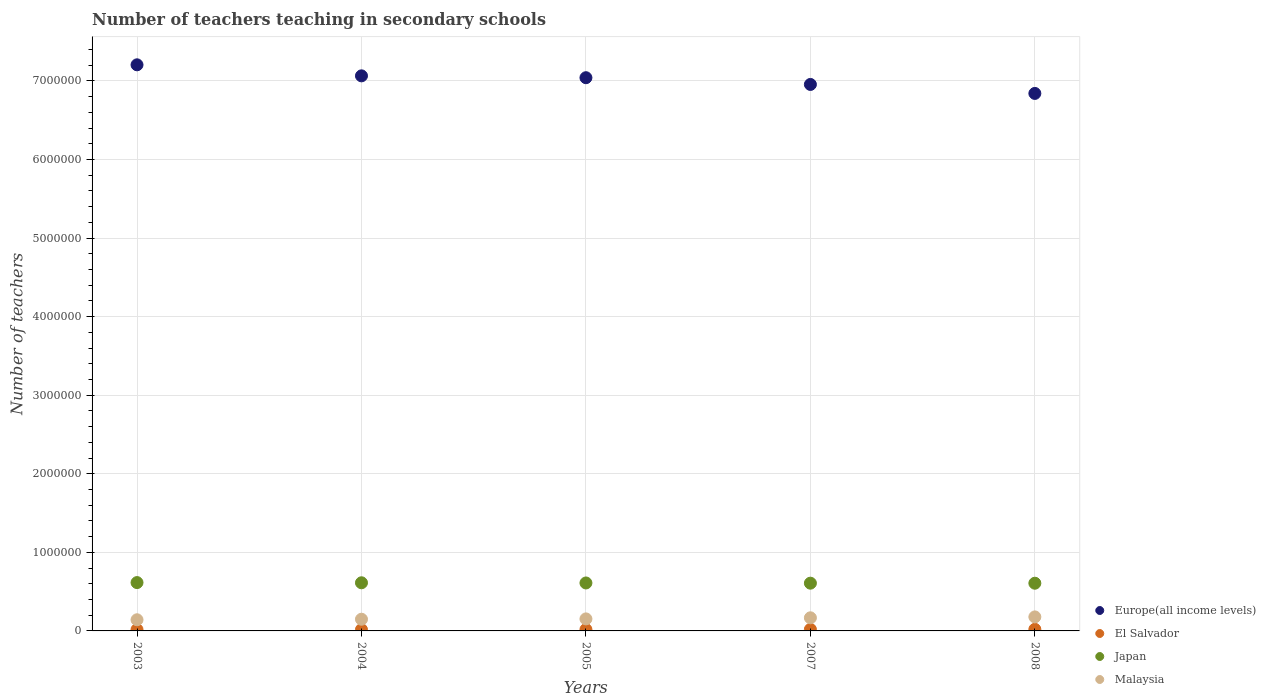Is the number of dotlines equal to the number of legend labels?
Offer a terse response. Yes. What is the number of teachers teaching in secondary schools in Europe(all income levels) in 2003?
Offer a terse response. 7.20e+06. Across all years, what is the maximum number of teachers teaching in secondary schools in Japan?
Give a very brief answer. 6.15e+05. Across all years, what is the minimum number of teachers teaching in secondary schools in Europe(all income levels)?
Your answer should be very brief. 6.84e+06. In which year was the number of teachers teaching in secondary schools in Japan maximum?
Your answer should be very brief. 2003. What is the total number of teachers teaching in secondary schools in Malaysia in the graph?
Give a very brief answer. 7.89e+05. What is the difference between the number of teachers teaching in secondary schools in Japan in 2003 and that in 2007?
Ensure brevity in your answer.  7495. What is the difference between the number of teachers teaching in secondary schools in Malaysia in 2005 and the number of teachers teaching in secondary schools in Japan in 2008?
Provide a short and direct response. -4.54e+05. What is the average number of teachers teaching in secondary schools in Europe(all income levels) per year?
Offer a very short reply. 7.02e+06. In the year 2003, what is the difference between the number of teachers teaching in secondary schools in Malaysia and number of teachers teaching in secondary schools in Japan?
Your response must be concise. -4.73e+05. What is the ratio of the number of teachers teaching in secondary schools in El Salvador in 2005 to that in 2007?
Provide a succinct answer. 0.91. What is the difference between the highest and the second highest number of teachers teaching in secondary schools in Japan?
Offer a terse response. 2529. What is the difference between the highest and the lowest number of teachers teaching in secondary schools in El Salvador?
Provide a short and direct response. 3652. In how many years, is the number of teachers teaching in secondary schools in El Salvador greater than the average number of teachers teaching in secondary schools in El Salvador taken over all years?
Your answer should be very brief. 2. Is the sum of the number of teachers teaching in secondary schools in Japan in 2003 and 2004 greater than the maximum number of teachers teaching in secondary schools in Malaysia across all years?
Your response must be concise. Yes. Is it the case that in every year, the sum of the number of teachers teaching in secondary schools in Europe(all income levels) and number of teachers teaching in secondary schools in Malaysia  is greater than the sum of number of teachers teaching in secondary schools in Japan and number of teachers teaching in secondary schools in El Salvador?
Your answer should be compact. Yes. Does the number of teachers teaching in secondary schools in Europe(all income levels) monotonically increase over the years?
Offer a very short reply. No. Is the number of teachers teaching in secondary schools in El Salvador strictly greater than the number of teachers teaching in secondary schools in Malaysia over the years?
Give a very brief answer. No. Is the number of teachers teaching in secondary schools in Japan strictly less than the number of teachers teaching in secondary schools in Europe(all income levels) over the years?
Make the answer very short. Yes. How many dotlines are there?
Your response must be concise. 4. Are the values on the major ticks of Y-axis written in scientific E-notation?
Provide a short and direct response. No. Where does the legend appear in the graph?
Offer a terse response. Bottom right. How many legend labels are there?
Your answer should be compact. 4. How are the legend labels stacked?
Your answer should be very brief. Vertical. What is the title of the graph?
Offer a very short reply. Number of teachers teaching in secondary schools. Does "Belarus" appear as one of the legend labels in the graph?
Offer a terse response. No. What is the label or title of the X-axis?
Give a very brief answer. Years. What is the label or title of the Y-axis?
Provide a short and direct response. Number of teachers. What is the Number of teachers of Europe(all income levels) in 2003?
Provide a short and direct response. 7.20e+06. What is the Number of teachers of El Salvador in 2003?
Your answer should be very brief. 1.68e+04. What is the Number of teachers in Japan in 2003?
Offer a very short reply. 6.15e+05. What is the Number of teachers in Malaysia in 2003?
Your answer should be very brief. 1.42e+05. What is the Number of teachers in Europe(all income levels) in 2004?
Offer a terse response. 7.06e+06. What is the Number of teachers of El Salvador in 2004?
Provide a succinct answer. 1.72e+04. What is the Number of teachers of Japan in 2004?
Provide a succinct answer. 6.13e+05. What is the Number of teachers of Malaysia in 2004?
Keep it short and to the point. 1.49e+05. What is the Number of teachers of Europe(all income levels) in 2005?
Provide a succinct answer. 7.04e+06. What is the Number of teachers in El Salvador in 2005?
Offer a very short reply. 1.81e+04. What is the Number of teachers of Japan in 2005?
Ensure brevity in your answer.  6.10e+05. What is the Number of teachers in Malaysia in 2005?
Make the answer very short. 1.53e+05. What is the Number of teachers of Europe(all income levels) in 2007?
Make the answer very short. 6.95e+06. What is the Number of teachers in El Salvador in 2007?
Your answer should be compact. 1.99e+04. What is the Number of teachers of Japan in 2007?
Your answer should be compact. 6.08e+05. What is the Number of teachers in Malaysia in 2007?
Your answer should be compact. 1.67e+05. What is the Number of teachers of Europe(all income levels) in 2008?
Offer a very short reply. 6.84e+06. What is the Number of teachers in El Salvador in 2008?
Provide a succinct answer. 2.05e+04. What is the Number of teachers of Japan in 2008?
Keep it short and to the point. 6.07e+05. What is the Number of teachers of Malaysia in 2008?
Provide a short and direct response. 1.78e+05. Across all years, what is the maximum Number of teachers in Europe(all income levels)?
Your response must be concise. 7.20e+06. Across all years, what is the maximum Number of teachers in El Salvador?
Make the answer very short. 2.05e+04. Across all years, what is the maximum Number of teachers of Japan?
Provide a short and direct response. 6.15e+05. Across all years, what is the maximum Number of teachers in Malaysia?
Provide a short and direct response. 1.78e+05. Across all years, what is the minimum Number of teachers in Europe(all income levels)?
Provide a succinct answer. 6.84e+06. Across all years, what is the minimum Number of teachers of El Salvador?
Your answer should be very brief. 1.68e+04. Across all years, what is the minimum Number of teachers of Japan?
Provide a short and direct response. 6.07e+05. Across all years, what is the minimum Number of teachers in Malaysia?
Offer a very short reply. 1.42e+05. What is the total Number of teachers of Europe(all income levels) in the graph?
Give a very brief answer. 3.51e+07. What is the total Number of teachers in El Salvador in the graph?
Offer a terse response. 9.26e+04. What is the total Number of teachers in Japan in the graph?
Your answer should be compact. 3.05e+06. What is the total Number of teachers in Malaysia in the graph?
Make the answer very short. 7.89e+05. What is the difference between the Number of teachers in Europe(all income levels) in 2003 and that in 2004?
Your response must be concise. 1.40e+05. What is the difference between the Number of teachers of El Salvador in 2003 and that in 2004?
Ensure brevity in your answer.  -367. What is the difference between the Number of teachers in Japan in 2003 and that in 2004?
Make the answer very short. 2529. What is the difference between the Number of teachers in Malaysia in 2003 and that in 2004?
Ensure brevity in your answer.  -6911. What is the difference between the Number of teachers of Europe(all income levels) in 2003 and that in 2005?
Make the answer very short. 1.64e+05. What is the difference between the Number of teachers in El Salvador in 2003 and that in 2005?
Offer a very short reply. -1294. What is the difference between the Number of teachers of Japan in 2003 and that in 2005?
Offer a terse response. 4786. What is the difference between the Number of teachers of Malaysia in 2003 and that in 2005?
Ensure brevity in your answer.  -1.11e+04. What is the difference between the Number of teachers in Europe(all income levels) in 2003 and that in 2007?
Provide a short and direct response. 2.50e+05. What is the difference between the Number of teachers in El Salvador in 2003 and that in 2007?
Keep it short and to the point. -3097. What is the difference between the Number of teachers of Japan in 2003 and that in 2007?
Provide a short and direct response. 7495. What is the difference between the Number of teachers of Malaysia in 2003 and that in 2007?
Provide a short and direct response. -2.50e+04. What is the difference between the Number of teachers in Europe(all income levels) in 2003 and that in 2008?
Offer a very short reply. 3.64e+05. What is the difference between the Number of teachers of El Salvador in 2003 and that in 2008?
Ensure brevity in your answer.  -3652. What is the difference between the Number of teachers of Japan in 2003 and that in 2008?
Give a very brief answer. 8096. What is the difference between the Number of teachers of Malaysia in 2003 and that in 2008?
Your response must be concise. -3.65e+04. What is the difference between the Number of teachers of Europe(all income levels) in 2004 and that in 2005?
Provide a succinct answer. 2.37e+04. What is the difference between the Number of teachers of El Salvador in 2004 and that in 2005?
Offer a terse response. -927. What is the difference between the Number of teachers in Japan in 2004 and that in 2005?
Offer a very short reply. 2257. What is the difference between the Number of teachers in Malaysia in 2004 and that in 2005?
Make the answer very short. -4207. What is the difference between the Number of teachers in Europe(all income levels) in 2004 and that in 2007?
Ensure brevity in your answer.  1.09e+05. What is the difference between the Number of teachers of El Salvador in 2004 and that in 2007?
Offer a very short reply. -2730. What is the difference between the Number of teachers of Japan in 2004 and that in 2007?
Make the answer very short. 4966. What is the difference between the Number of teachers of Malaysia in 2004 and that in 2007?
Provide a short and direct response. -1.81e+04. What is the difference between the Number of teachers in Europe(all income levels) in 2004 and that in 2008?
Ensure brevity in your answer.  2.24e+05. What is the difference between the Number of teachers in El Salvador in 2004 and that in 2008?
Make the answer very short. -3285. What is the difference between the Number of teachers of Japan in 2004 and that in 2008?
Your answer should be very brief. 5567. What is the difference between the Number of teachers of Malaysia in 2004 and that in 2008?
Provide a short and direct response. -2.96e+04. What is the difference between the Number of teachers of Europe(all income levels) in 2005 and that in 2007?
Your response must be concise. 8.57e+04. What is the difference between the Number of teachers in El Salvador in 2005 and that in 2007?
Make the answer very short. -1803. What is the difference between the Number of teachers in Japan in 2005 and that in 2007?
Make the answer very short. 2709. What is the difference between the Number of teachers in Malaysia in 2005 and that in 2007?
Give a very brief answer. -1.39e+04. What is the difference between the Number of teachers of Europe(all income levels) in 2005 and that in 2008?
Provide a short and direct response. 2.00e+05. What is the difference between the Number of teachers in El Salvador in 2005 and that in 2008?
Offer a terse response. -2358. What is the difference between the Number of teachers of Japan in 2005 and that in 2008?
Your answer should be very brief. 3310. What is the difference between the Number of teachers in Malaysia in 2005 and that in 2008?
Offer a terse response. -2.53e+04. What is the difference between the Number of teachers in Europe(all income levels) in 2007 and that in 2008?
Your response must be concise. 1.14e+05. What is the difference between the Number of teachers of El Salvador in 2007 and that in 2008?
Offer a terse response. -555. What is the difference between the Number of teachers of Japan in 2007 and that in 2008?
Ensure brevity in your answer.  601. What is the difference between the Number of teachers in Malaysia in 2007 and that in 2008?
Offer a terse response. -1.14e+04. What is the difference between the Number of teachers of Europe(all income levels) in 2003 and the Number of teachers of El Salvador in 2004?
Offer a very short reply. 7.19e+06. What is the difference between the Number of teachers in Europe(all income levels) in 2003 and the Number of teachers in Japan in 2004?
Your response must be concise. 6.59e+06. What is the difference between the Number of teachers of Europe(all income levels) in 2003 and the Number of teachers of Malaysia in 2004?
Your answer should be compact. 7.06e+06. What is the difference between the Number of teachers of El Salvador in 2003 and the Number of teachers of Japan in 2004?
Offer a terse response. -5.96e+05. What is the difference between the Number of teachers of El Salvador in 2003 and the Number of teachers of Malaysia in 2004?
Your response must be concise. -1.32e+05. What is the difference between the Number of teachers of Japan in 2003 and the Number of teachers of Malaysia in 2004?
Your response must be concise. 4.66e+05. What is the difference between the Number of teachers of Europe(all income levels) in 2003 and the Number of teachers of El Salvador in 2005?
Ensure brevity in your answer.  7.19e+06. What is the difference between the Number of teachers in Europe(all income levels) in 2003 and the Number of teachers in Japan in 2005?
Offer a very short reply. 6.59e+06. What is the difference between the Number of teachers in Europe(all income levels) in 2003 and the Number of teachers in Malaysia in 2005?
Provide a short and direct response. 7.05e+06. What is the difference between the Number of teachers of El Salvador in 2003 and the Number of teachers of Japan in 2005?
Offer a terse response. -5.94e+05. What is the difference between the Number of teachers in El Salvador in 2003 and the Number of teachers in Malaysia in 2005?
Offer a terse response. -1.36e+05. What is the difference between the Number of teachers of Japan in 2003 and the Number of teachers of Malaysia in 2005?
Your answer should be compact. 4.62e+05. What is the difference between the Number of teachers of Europe(all income levels) in 2003 and the Number of teachers of El Salvador in 2007?
Offer a terse response. 7.18e+06. What is the difference between the Number of teachers of Europe(all income levels) in 2003 and the Number of teachers of Japan in 2007?
Give a very brief answer. 6.60e+06. What is the difference between the Number of teachers of Europe(all income levels) in 2003 and the Number of teachers of Malaysia in 2007?
Ensure brevity in your answer.  7.04e+06. What is the difference between the Number of teachers in El Salvador in 2003 and the Number of teachers in Japan in 2007?
Your response must be concise. -5.91e+05. What is the difference between the Number of teachers in El Salvador in 2003 and the Number of teachers in Malaysia in 2007?
Give a very brief answer. -1.50e+05. What is the difference between the Number of teachers in Japan in 2003 and the Number of teachers in Malaysia in 2007?
Keep it short and to the point. 4.48e+05. What is the difference between the Number of teachers of Europe(all income levels) in 2003 and the Number of teachers of El Salvador in 2008?
Give a very brief answer. 7.18e+06. What is the difference between the Number of teachers in Europe(all income levels) in 2003 and the Number of teachers in Japan in 2008?
Offer a very short reply. 6.60e+06. What is the difference between the Number of teachers in Europe(all income levels) in 2003 and the Number of teachers in Malaysia in 2008?
Your answer should be very brief. 7.03e+06. What is the difference between the Number of teachers in El Salvador in 2003 and the Number of teachers in Japan in 2008?
Keep it short and to the point. -5.90e+05. What is the difference between the Number of teachers in El Salvador in 2003 and the Number of teachers in Malaysia in 2008?
Provide a short and direct response. -1.62e+05. What is the difference between the Number of teachers of Japan in 2003 and the Number of teachers of Malaysia in 2008?
Your answer should be compact. 4.37e+05. What is the difference between the Number of teachers in Europe(all income levels) in 2004 and the Number of teachers in El Salvador in 2005?
Ensure brevity in your answer.  7.05e+06. What is the difference between the Number of teachers in Europe(all income levels) in 2004 and the Number of teachers in Japan in 2005?
Offer a terse response. 6.45e+06. What is the difference between the Number of teachers in Europe(all income levels) in 2004 and the Number of teachers in Malaysia in 2005?
Provide a succinct answer. 6.91e+06. What is the difference between the Number of teachers in El Salvador in 2004 and the Number of teachers in Japan in 2005?
Provide a succinct answer. -5.93e+05. What is the difference between the Number of teachers of El Salvador in 2004 and the Number of teachers of Malaysia in 2005?
Ensure brevity in your answer.  -1.36e+05. What is the difference between the Number of teachers of Japan in 2004 and the Number of teachers of Malaysia in 2005?
Keep it short and to the point. 4.60e+05. What is the difference between the Number of teachers in Europe(all income levels) in 2004 and the Number of teachers in El Salvador in 2007?
Offer a very short reply. 7.04e+06. What is the difference between the Number of teachers in Europe(all income levels) in 2004 and the Number of teachers in Japan in 2007?
Keep it short and to the point. 6.46e+06. What is the difference between the Number of teachers of Europe(all income levels) in 2004 and the Number of teachers of Malaysia in 2007?
Ensure brevity in your answer.  6.90e+06. What is the difference between the Number of teachers of El Salvador in 2004 and the Number of teachers of Japan in 2007?
Ensure brevity in your answer.  -5.90e+05. What is the difference between the Number of teachers of El Salvador in 2004 and the Number of teachers of Malaysia in 2007?
Your answer should be compact. -1.50e+05. What is the difference between the Number of teachers in Japan in 2004 and the Number of teachers in Malaysia in 2007?
Offer a very short reply. 4.46e+05. What is the difference between the Number of teachers in Europe(all income levels) in 2004 and the Number of teachers in El Salvador in 2008?
Keep it short and to the point. 7.04e+06. What is the difference between the Number of teachers in Europe(all income levels) in 2004 and the Number of teachers in Japan in 2008?
Provide a succinct answer. 6.46e+06. What is the difference between the Number of teachers of Europe(all income levels) in 2004 and the Number of teachers of Malaysia in 2008?
Your answer should be compact. 6.89e+06. What is the difference between the Number of teachers of El Salvador in 2004 and the Number of teachers of Japan in 2008?
Give a very brief answer. -5.90e+05. What is the difference between the Number of teachers of El Salvador in 2004 and the Number of teachers of Malaysia in 2008?
Your response must be concise. -1.61e+05. What is the difference between the Number of teachers of Japan in 2004 and the Number of teachers of Malaysia in 2008?
Your answer should be compact. 4.34e+05. What is the difference between the Number of teachers in Europe(all income levels) in 2005 and the Number of teachers in El Salvador in 2007?
Keep it short and to the point. 7.02e+06. What is the difference between the Number of teachers of Europe(all income levels) in 2005 and the Number of teachers of Japan in 2007?
Give a very brief answer. 6.43e+06. What is the difference between the Number of teachers of Europe(all income levels) in 2005 and the Number of teachers of Malaysia in 2007?
Provide a succinct answer. 6.87e+06. What is the difference between the Number of teachers in El Salvador in 2005 and the Number of teachers in Japan in 2007?
Give a very brief answer. -5.90e+05. What is the difference between the Number of teachers of El Salvador in 2005 and the Number of teachers of Malaysia in 2007?
Offer a terse response. -1.49e+05. What is the difference between the Number of teachers in Japan in 2005 and the Number of teachers in Malaysia in 2007?
Make the answer very short. 4.43e+05. What is the difference between the Number of teachers in Europe(all income levels) in 2005 and the Number of teachers in El Salvador in 2008?
Offer a very short reply. 7.02e+06. What is the difference between the Number of teachers in Europe(all income levels) in 2005 and the Number of teachers in Japan in 2008?
Give a very brief answer. 6.43e+06. What is the difference between the Number of teachers of Europe(all income levels) in 2005 and the Number of teachers of Malaysia in 2008?
Provide a succinct answer. 6.86e+06. What is the difference between the Number of teachers of El Salvador in 2005 and the Number of teachers of Japan in 2008?
Keep it short and to the point. -5.89e+05. What is the difference between the Number of teachers in El Salvador in 2005 and the Number of teachers in Malaysia in 2008?
Your answer should be compact. -1.60e+05. What is the difference between the Number of teachers in Japan in 2005 and the Number of teachers in Malaysia in 2008?
Offer a very short reply. 4.32e+05. What is the difference between the Number of teachers in Europe(all income levels) in 2007 and the Number of teachers in El Salvador in 2008?
Offer a very short reply. 6.93e+06. What is the difference between the Number of teachers in Europe(all income levels) in 2007 and the Number of teachers in Japan in 2008?
Offer a terse response. 6.35e+06. What is the difference between the Number of teachers of Europe(all income levels) in 2007 and the Number of teachers of Malaysia in 2008?
Your answer should be very brief. 6.78e+06. What is the difference between the Number of teachers in El Salvador in 2007 and the Number of teachers in Japan in 2008?
Your response must be concise. -5.87e+05. What is the difference between the Number of teachers of El Salvador in 2007 and the Number of teachers of Malaysia in 2008?
Give a very brief answer. -1.58e+05. What is the difference between the Number of teachers of Japan in 2007 and the Number of teachers of Malaysia in 2008?
Keep it short and to the point. 4.29e+05. What is the average Number of teachers of Europe(all income levels) per year?
Provide a succinct answer. 7.02e+06. What is the average Number of teachers of El Salvador per year?
Offer a very short reply. 1.85e+04. What is the average Number of teachers in Japan per year?
Give a very brief answer. 6.11e+05. What is the average Number of teachers in Malaysia per year?
Keep it short and to the point. 1.58e+05. In the year 2003, what is the difference between the Number of teachers of Europe(all income levels) and Number of teachers of El Salvador?
Your response must be concise. 7.19e+06. In the year 2003, what is the difference between the Number of teachers of Europe(all income levels) and Number of teachers of Japan?
Make the answer very short. 6.59e+06. In the year 2003, what is the difference between the Number of teachers in Europe(all income levels) and Number of teachers in Malaysia?
Your response must be concise. 7.06e+06. In the year 2003, what is the difference between the Number of teachers of El Salvador and Number of teachers of Japan?
Make the answer very short. -5.98e+05. In the year 2003, what is the difference between the Number of teachers in El Salvador and Number of teachers in Malaysia?
Your answer should be compact. -1.25e+05. In the year 2003, what is the difference between the Number of teachers in Japan and Number of teachers in Malaysia?
Your answer should be compact. 4.73e+05. In the year 2004, what is the difference between the Number of teachers in Europe(all income levels) and Number of teachers in El Salvador?
Give a very brief answer. 7.05e+06. In the year 2004, what is the difference between the Number of teachers in Europe(all income levels) and Number of teachers in Japan?
Give a very brief answer. 6.45e+06. In the year 2004, what is the difference between the Number of teachers of Europe(all income levels) and Number of teachers of Malaysia?
Keep it short and to the point. 6.92e+06. In the year 2004, what is the difference between the Number of teachers in El Salvador and Number of teachers in Japan?
Provide a short and direct response. -5.95e+05. In the year 2004, what is the difference between the Number of teachers of El Salvador and Number of teachers of Malaysia?
Ensure brevity in your answer.  -1.32e+05. In the year 2004, what is the difference between the Number of teachers of Japan and Number of teachers of Malaysia?
Offer a very short reply. 4.64e+05. In the year 2005, what is the difference between the Number of teachers of Europe(all income levels) and Number of teachers of El Salvador?
Provide a succinct answer. 7.02e+06. In the year 2005, what is the difference between the Number of teachers of Europe(all income levels) and Number of teachers of Japan?
Provide a short and direct response. 6.43e+06. In the year 2005, what is the difference between the Number of teachers of Europe(all income levels) and Number of teachers of Malaysia?
Provide a succinct answer. 6.89e+06. In the year 2005, what is the difference between the Number of teachers in El Salvador and Number of teachers in Japan?
Give a very brief answer. -5.92e+05. In the year 2005, what is the difference between the Number of teachers of El Salvador and Number of teachers of Malaysia?
Provide a short and direct response. -1.35e+05. In the year 2005, what is the difference between the Number of teachers of Japan and Number of teachers of Malaysia?
Keep it short and to the point. 4.57e+05. In the year 2007, what is the difference between the Number of teachers of Europe(all income levels) and Number of teachers of El Salvador?
Provide a short and direct response. 6.93e+06. In the year 2007, what is the difference between the Number of teachers in Europe(all income levels) and Number of teachers in Japan?
Make the answer very short. 6.35e+06. In the year 2007, what is the difference between the Number of teachers in Europe(all income levels) and Number of teachers in Malaysia?
Your answer should be very brief. 6.79e+06. In the year 2007, what is the difference between the Number of teachers of El Salvador and Number of teachers of Japan?
Your answer should be compact. -5.88e+05. In the year 2007, what is the difference between the Number of teachers of El Salvador and Number of teachers of Malaysia?
Provide a succinct answer. -1.47e+05. In the year 2007, what is the difference between the Number of teachers in Japan and Number of teachers in Malaysia?
Provide a short and direct response. 4.41e+05. In the year 2008, what is the difference between the Number of teachers of Europe(all income levels) and Number of teachers of El Salvador?
Provide a succinct answer. 6.82e+06. In the year 2008, what is the difference between the Number of teachers of Europe(all income levels) and Number of teachers of Japan?
Your answer should be very brief. 6.23e+06. In the year 2008, what is the difference between the Number of teachers of Europe(all income levels) and Number of teachers of Malaysia?
Your answer should be very brief. 6.66e+06. In the year 2008, what is the difference between the Number of teachers in El Salvador and Number of teachers in Japan?
Offer a terse response. -5.87e+05. In the year 2008, what is the difference between the Number of teachers of El Salvador and Number of teachers of Malaysia?
Your response must be concise. -1.58e+05. In the year 2008, what is the difference between the Number of teachers in Japan and Number of teachers in Malaysia?
Your answer should be compact. 4.29e+05. What is the ratio of the Number of teachers in Europe(all income levels) in 2003 to that in 2004?
Give a very brief answer. 1.02. What is the ratio of the Number of teachers of El Salvador in 2003 to that in 2004?
Provide a succinct answer. 0.98. What is the ratio of the Number of teachers in Malaysia in 2003 to that in 2004?
Your answer should be compact. 0.95. What is the ratio of the Number of teachers in Europe(all income levels) in 2003 to that in 2005?
Make the answer very short. 1.02. What is the ratio of the Number of teachers of El Salvador in 2003 to that in 2005?
Make the answer very short. 0.93. What is the ratio of the Number of teachers of Malaysia in 2003 to that in 2005?
Your answer should be very brief. 0.93. What is the ratio of the Number of teachers in Europe(all income levels) in 2003 to that in 2007?
Provide a short and direct response. 1.04. What is the ratio of the Number of teachers in El Salvador in 2003 to that in 2007?
Give a very brief answer. 0.84. What is the ratio of the Number of teachers of Japan in 2003 to that in 2007?
Provide a short and direct response. 1.01. What is the ratio of the Number of teachers in Malaysia in 2003 to that in 2007?
Make the answer very short. 0.85. What is the ratio of the Number of teachers in Europe(all income levels) in 2003 to that in 2008?
Keep it short and to the point. 1.05. What is the ratio of the Number of teachers in El Salvador in 2003 to that in 2008?
Make the answer very short. 0.82. What is the ratio of the Number of teachers of Japan in 2003 to that in 2008?
Keep it short and to the point. 1.01. What is the ratio of the Number of teachers of Malaysia in 2003 to that in 2008?
Give a very brief answer. 0.8. What is the ratio of the Number of teachers of El Salvador in 2004 to that in 2005?
Offer a terse response. 0.95. What is the ratio of the Number of teachers of Japan in 2004 to that in 2005?
Offer a terse response. 1. What is the ratio of the Number of teachers of Malaysia in 2004 to that in 2005?
Provide a short and direct response. 0.97. What is the ratio of the Number of teachers of Europe(all income levels) in 2004 to that in 2007?
Provide a short and direct response. 1.02. What is the ratio of the Number of teachers in El Salvador in 2004 to that in 2007?
Keep it short and to the point. 0.86. What is the ratio of the Number of teachers in Japan in 2004 to that in 2007?
Your answer should be compact. 1.01. What is the ratio of the Number of teachers in Malaysia in 2004 to that in 2007?
Provide a short and direct response. 0.89. What is the ratio of the Number of teachers in Europe(all income levels) in 2004 to that in 2008?
Ensure brevity in your answer.  1.03. What is the ratio of the Number of teachers in El Salvador in 2004 to that in 2008?
Offer a terse response. 0.84. What is the ratio of the Number of teachers in Japan in 2004 to that in 2008?
Your answer should be compact. 1.01. What is the ratio of the Number of teachers in Malaysia in 2004 to that in 2008?
Your response must be concise. 0.83. What is the ratio of the Number of teachers in Europe(all income levels) in 2005 to that in 2007?
Offer a terse response. 1.01. What is the ratio of the Number of teachers of El Salvador in 2005 to that in 2007?
Provide a succinct answer. 0.91. What is the ratio of the Number of teachers in Japan in 2005 to that in 2007?
Offer a very short reply. 1. What is the ratio of the Number of teachers of Europe(all income levels) in 2005 to that in 2008?
Offer a terse response. 1.03. What is the ratio of the Number of teachers of El Salvador in 2005 to that in 2008?
Ensure brevity in your answer.  0.88. What is the ratio of the Number of teachers of Malaysia in 2005 to that in 2008?
Offer a very short reply. 0.86. What is the ratio of the Number of teachers in Europe(all income levels) in 2007 to that in 2008?
Your answer should be compact. 1.02. What is the ratio of the Number of teachers in El Salvador in 2007 to that in 2008?
Your answer should be very brief. 0.97. What is the ratio of the Number of teachers of Malaysia in 2007 to that in 2008?
Offer a very short reply. 0.94. What is the difference between the highest and the second highest Number of teachers of Europe(all income levels)?
Provide a succinct answer. 1.40e+05. What is the difference between the highest and the second highest Number of teachers of El Salvador?
Give a very brief answer. 555. What is the difference between the highest and the second highest Number of teachers of Japan?
Your response must be concise. 2529. What is the difference between the highest and the second highest Number of teachers of Malaysia?
Offer a very short reply. 1.14e+04. What is the difference between the highest and the lowest Number of teachers of Europe(all income levels)?
Your answer should be very brief. 3.64e+05. What is the difference between the highest and the lowest Number of teachers in El Salvador?
Your response must be concise. 3652. What is the difference between the highest and the lowest Number of teachers in Japan?
Keep it short and to the point. 8096. What is the difference between the highest and the lowest Number of teachers of Malaysia?
Your answer should be compact. 3.65e+04. 